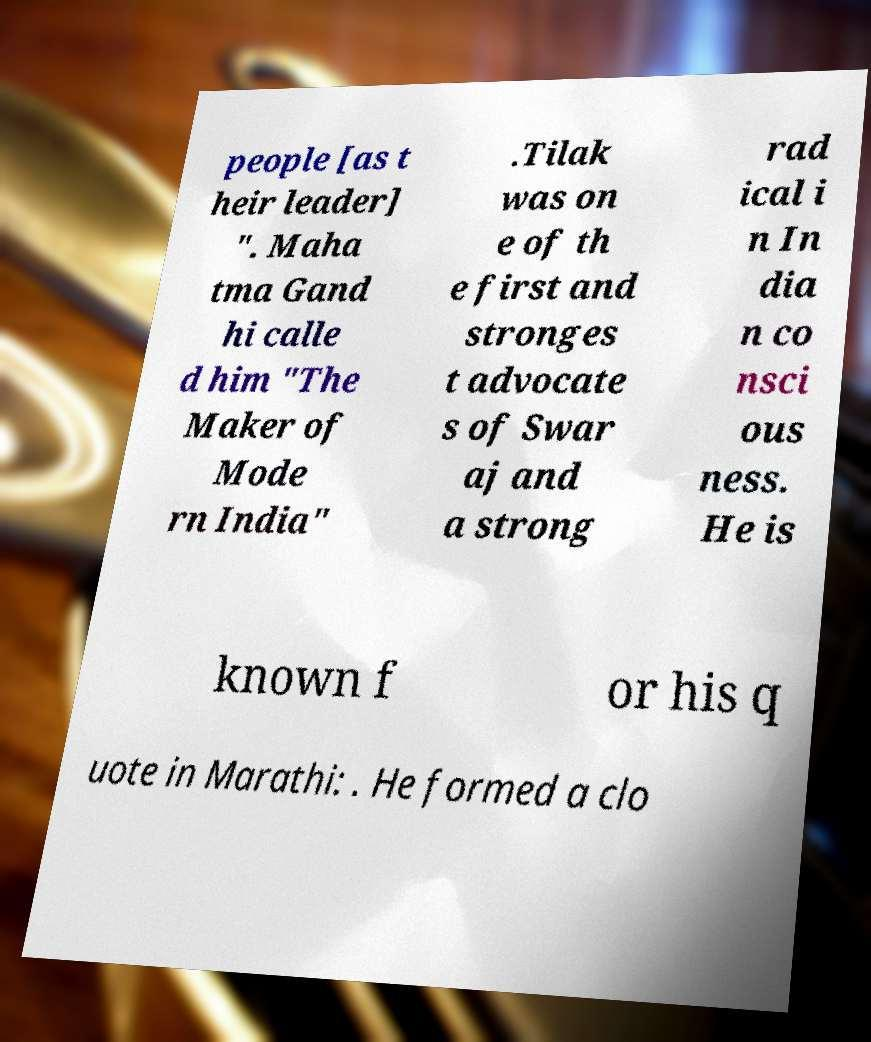There's text embedded in this image that I need extracted. Can you transcribe it verbatim? people [as t heir leader] ". Maha tma Gand hi calle d him "The Maker of Mode rn India" .Tilak was on e of th e first and stronges t advocate s of Swar aj and a strong rad ical i n In dia n co nsci ous ness. He is known f or his q uote in Marathi: . He formed a clo 